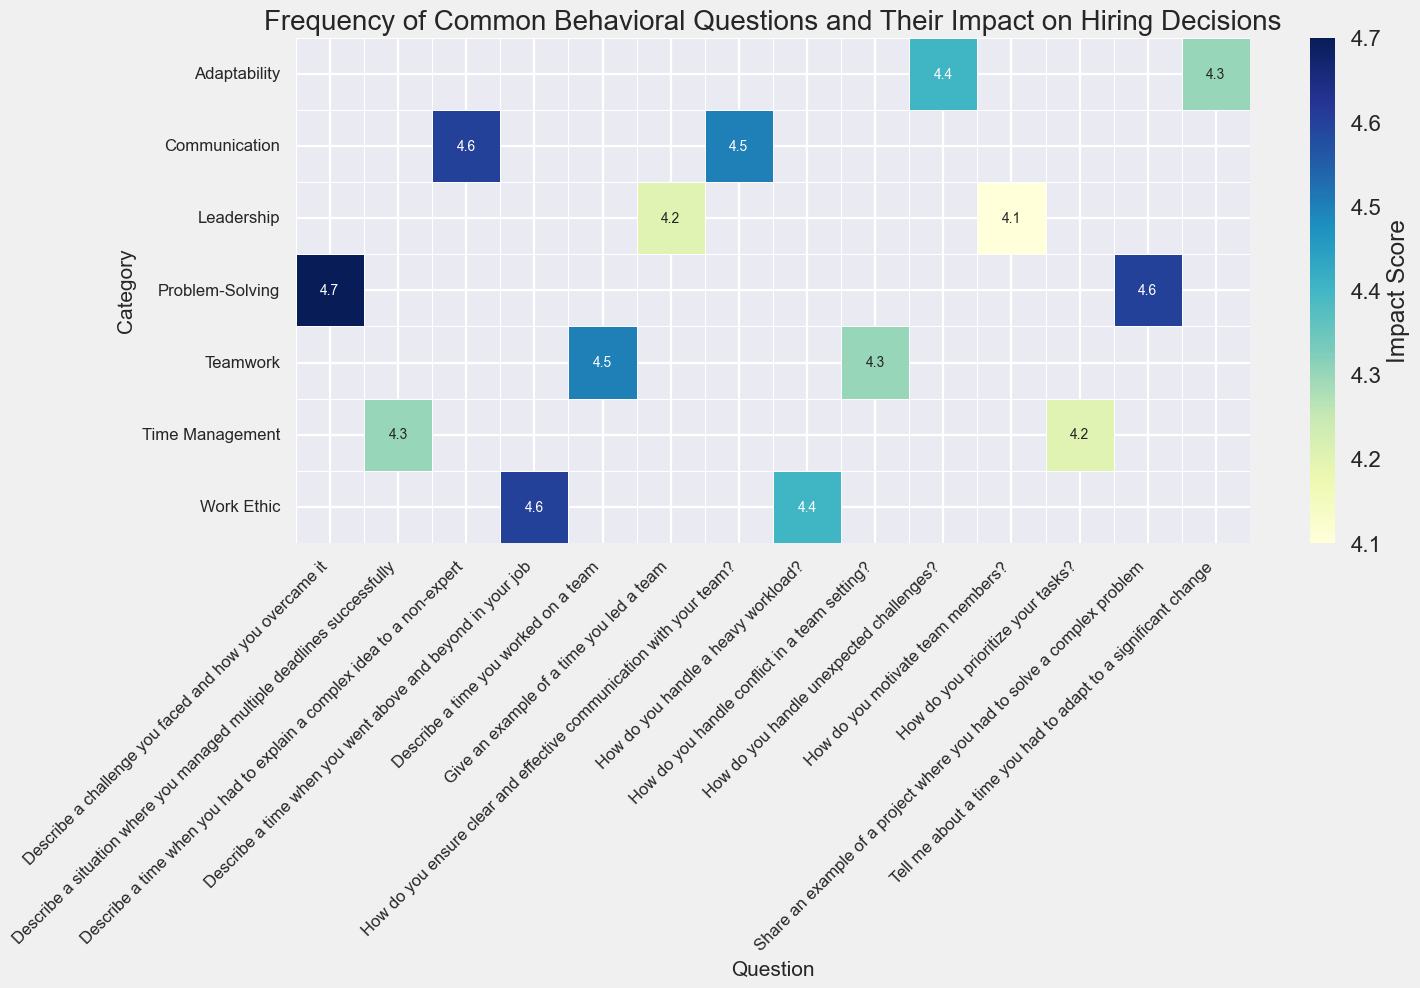Which category has the highest average impact score? To find the category with the highest average impact score, calculate the average of impact scores for each category. First, for Teamwork: (4.5 + 4.3) / 2 = 4.4. Next, for Problem-Solving: (4.7 + 4.6) / 2 = 4.65. Then for Leadership: (4.2 + 4.1) / 2 = 4.15. For Adaptability: (4.3 + 4.4) / 2 = 4.35. For Communication: (4.6 + 4.5) / 2 = 4.55. For Time Management: (4.2 + 4.3) / 2 = 4.25. And lastly, for Work Ethic: (4.6 + 4.4) / 2 = 4.5. Comparing these values, Problem-Solving has the highest average impact score of 4.65.
Answer: Problem-Solving Which question has the highest impact score? Look at the heatmap to find the highest impact score. The darkest green square will indicate the highest impact score. Here, the question "Describe a challenge you faced and how you overcame it" in the Problem-Solving category has the highest impact score of 4.7.
Answer: Describe a challenge you faced and how you overcame it How many questions have an impact score above 4.5? To count how many questions have an impact score above 4.5, identify the squares in the heatmap that are colored in the darkest and second darkest shades of green. These shades represent scores above 4.5. By counting them, we find the following questions: "Describe a challenge you faced and how you overcame it" (4.7), "Share an example of a project where you had to solve a complex problem" (4.6), "Describe a time when you had to explain a complex idea to a non-expert" (4.6), and "Describe a time you worked on a team" (4.5). There are 4 questions with an impact score above 4.5.
Answer: 4 Which two categories have the most similar average impact scores? Calculate the average impact scores for all categories first: Teamwork: (4.5 + 4.3) / 2 = 4.4, Problem-Solving: (4.7 + 4.6) / 2 = 4.65, Leadership: (4.2 + 4.1) / 2 = 4.15, Adaptability: (4.3 + 4.4) / 2 = 4.35, Communication: (4.6 + 4.5) / 2 = 4.55, Time Management: (4.2 + 4.3) / 2 = 4.25, Work Ethic: (4.6 + 4.4) / 2 = 4.5. Compare these averages to find the smallest difference. The smallest difference is between Teamwork (4.4) and Adaptability (4.35), with a difference of just 0.05.
Answer: Teamwork and Adaptability In which category are the questions with the lowest impact scores? Identify the lightest colored squares in the heatmap, indicating the lowest impact scores. Both questions in the Leadership category ("Give an example of a time you led a team" with 4.2, and "How do you motivate team members?" with 4.1) are the lightest and have the lowest impact scores.
Answer: Leadership What is the impact score for the question "How do you handle unexpected challenges?" and how does it compare to "Tell me about a time you had to adapt to a significant change”? Look at the Adaptability category in the heatmap for the impact scores. "How do you handle unexpected challenges?" has an impact score of 4.4, and "Tell me about a time you had to adapt to a significant change" has an impact score of 4.3. "How do you handle unexpected challenges?" has a slightly higher impact score compared to "Tell me about a time you had to adapt to a significant change."
Answer: 4.4; slightly higher Which category has the widest range of impact scores? Calculate the range for each category by subtracting the lowest impact score from the highest impact score in that category. For Teamwork, the range is 4.5 - 4.3 = 0.2. For Problem-Solving, the range is 4.7 - 4.6 = 0.1. For Leadership, the range is 4.2 - 4.1 = 0.1. For Adaptability, the range is 4.4 - 4.3 = 0.1. For Communication, the range is 4.6 - 4.5 = 0.1. For Time Management, the range is 4.3 - 4.2 = 0.1. For Work Ethic, the range is 4.6 - 4.4 = 0.2. Teamwork and Work Ethic have the widest range of impact scores, which is 0.2.
Answer: Teamwork and Work Ethic 